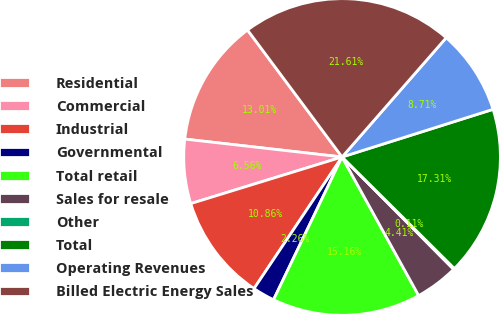Convert chart. <chart><loc_0><loc_0><loc_500><loc_500><pie_chart><fcel>Residential<fcel>Commercial<fcel>Industrial<fcel>Governmental<fcel>Total retail<fcel>Sales for resale<fcel>Other<fcel>Total<fcel>Operating Revenues<fcel>Billed Electric Energy Sales<nl><fcel>13.01%<fcel>6.56%<fcel>10.86%<fcel>2.26%<fcel>15.16%<fcel>4.41%<fcel>0.11%<fcel>17.31%<fcel>8.71%<fcel>21.61%<nl></chart> 